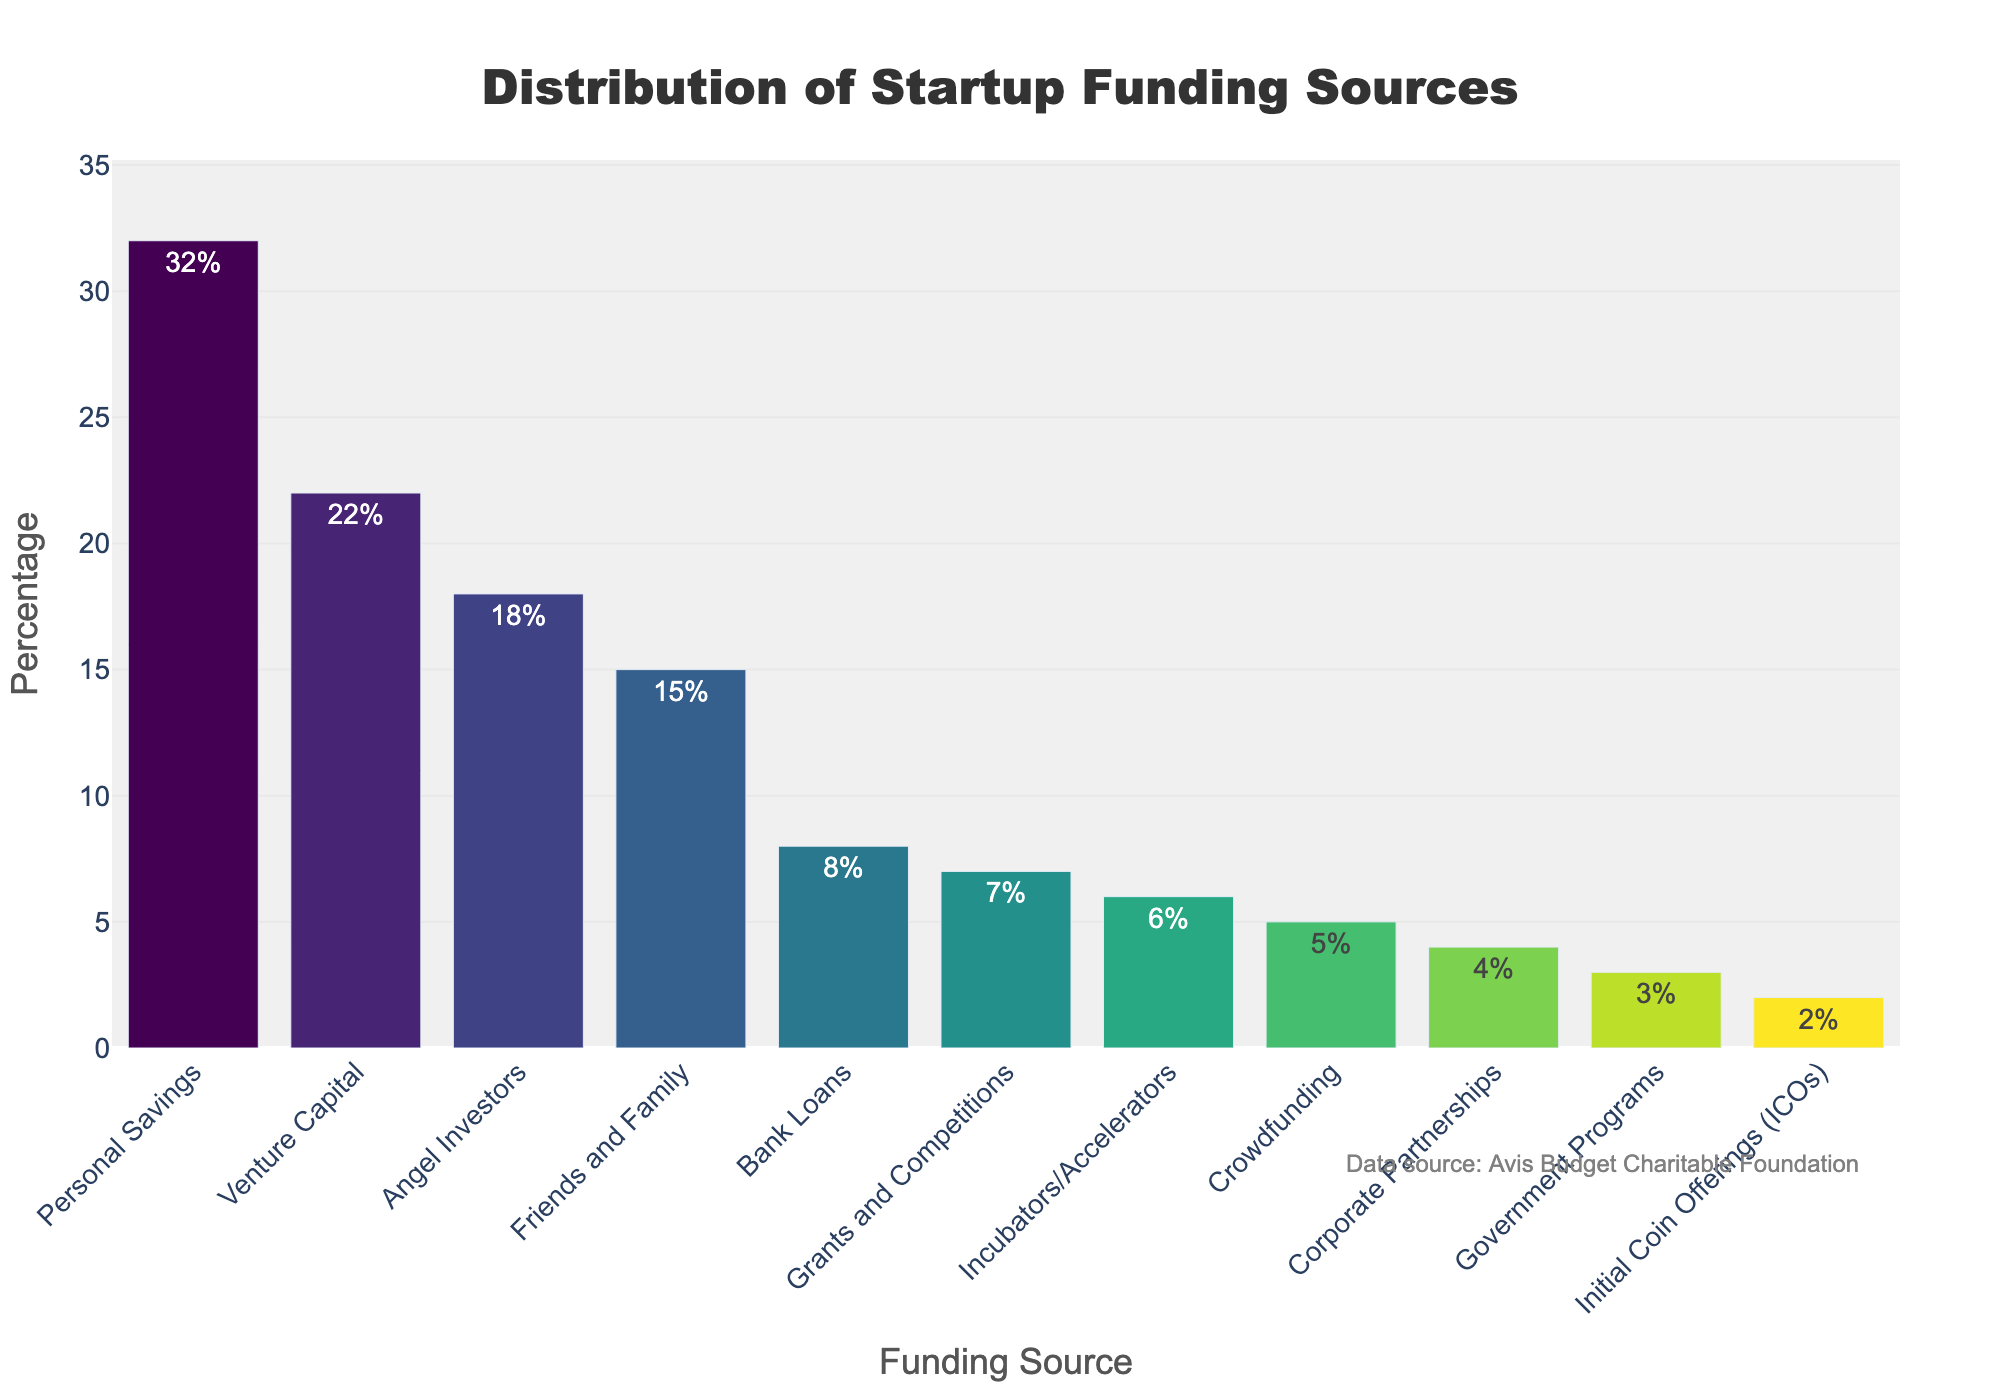How many funding sources contribute less than 5%? Identify all funding sources with percentages lower than 5% and count them: Initial Coin Offerings (2%) and Corporate Partnerships (4%), totaling 2 categories.
Answer: 2 Which funding source has the highest percentage? Look at the bar chart to identify the tallest bar which represents the highest percentage: Personal Savings (32%).
Answer: Personal Savings What is the percentage range of the top three funding sources? Sort the funding sources in descending order and observe the top three: Personal Savings (32%), Venture Capital (22%), and Angel Investors (18%). The range is from 32% to 18%.
Answer: 18%-32% Compare the combined percentage of Bank Loans and Crowdfunding to the percentage of Angel Investors. Which is greater? Add the percentages of Bank Loans (8%) and Crowdfunding (5%): 8% + 5% = 13%. Compare this to Angel Investors (18%). Angel Investors (18%) is greater than the combined percentage (13%).
Answer: Angel Investors What is the total percentage contributed by Personal Savings, Friends and Family, and Angel Investors? Add the percentages: Personal Savings (32%), Friends and Family (15%), and Angel Investors (18%). 32% + 15% + 18% = 65%.
Answer: 65% Which funding source has the smallest percentage and what is its value? Identify the shortest bar representing the smallest percentage: Initial Coin Offerings (ICOs) (2%).
Answer: Initial Coin Offerings (ICOs), 2% How does the height of the bar for Venture Capital compare to Friends and Family? Observe the heights of the bars: Venture Capital (22%) is higher than Friends and Family (15%).
Answer: Venture Capital is higher What is the average percentage of the sources that contribute more than 10%? Identify the sources greater than 10%: Personal Savings (32%), Friends and Family (15%), Angel Investors (18%), and Venture Capital (22%). Calculate the average: (32% + 15% + 18% + 22%) / 4 = 21.75%.
Answer: 21.75% Are there more sources contributing below 10% or above 10%? Count sources below 10% (Bank Loans, Crowdfunding, Grants and Competitions, Corporate Partnerships, Incubators/Accelerators, ICOs, Government Programs) totaling 7. Sources above 10% (Personal Savings, Friends and Family, Angel Investors, Venture Capital) total 4. There are more sources below 10%.
Answer: Below 10% What is the combined percentage of grants and competitions, government programs, and corporate partnerships? Add the percentages of Grants and Competitions (7%), Government Programs (3%), and Corporate Partnerships (4%). 7% + 3% + 4% = 14%.
Answer: 14% 